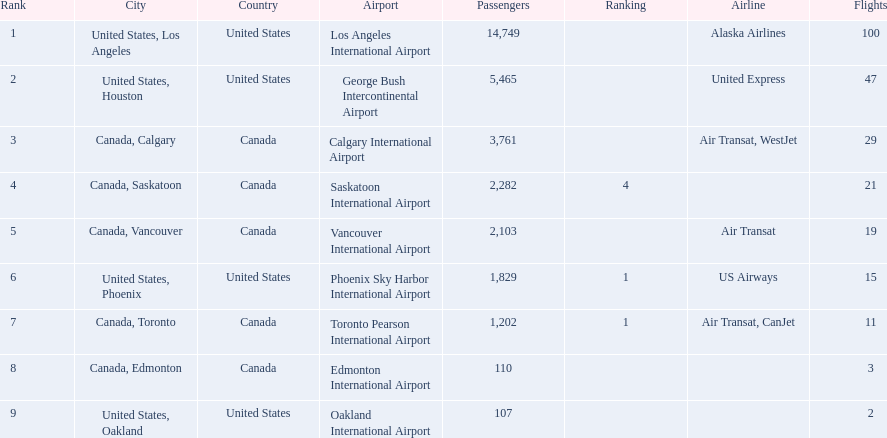Which airport has the least amount of passengers? 107. Write the full table. {'header': ['Rank', 'City', 'Country', 'Airport', 'Passengers', 'Ranking', 'Airline', 'Flights'], 'rows': [['1', 'United States, Los Angeles', 'United States', 'Los Angeles International Airport', '14,749', '', 'Alaska Airlines', '100'], ['2', 'United States, Houston', 'United States', 'George Bush Intercontinental Airport', '5,465', '', 'United Express', '47'], ['3', 'Canada, Calgary', 'Canada', 'Calgary International Airport', '3,761', '', 'Air Transat, WestJet', '29'], ['4', 'Canada, Saskatoon', 'Canada', 'Saskatoon International Airport', '2,282', '4', '', '21'], ['5', 'Canada, Vancouver', 'Canada', 'Vancouver International Airport', '2,103', '', 'Air Transat', '19'], ['6', 'United States, Phoenix', 'United States', 'Phoenix Sky Harbor International Airport', '1,829', '1', 'US Airways', '15'], ['7', 'Canada, Toronto', 'Canada', 'Toronto Pearson International Airport', '1,202', '1', 'Air Transat, CanJet', '11'], ['8', 'Canada, Edmonton', 'Canada', 'Edmonton International Airport', '110', '', '', '3'], ['9', 'United States, Oakland', 'United States', 'Oakland International Airport', '107', '', '', '2']]} What airport has 107 passengers? United States, Oakland. 